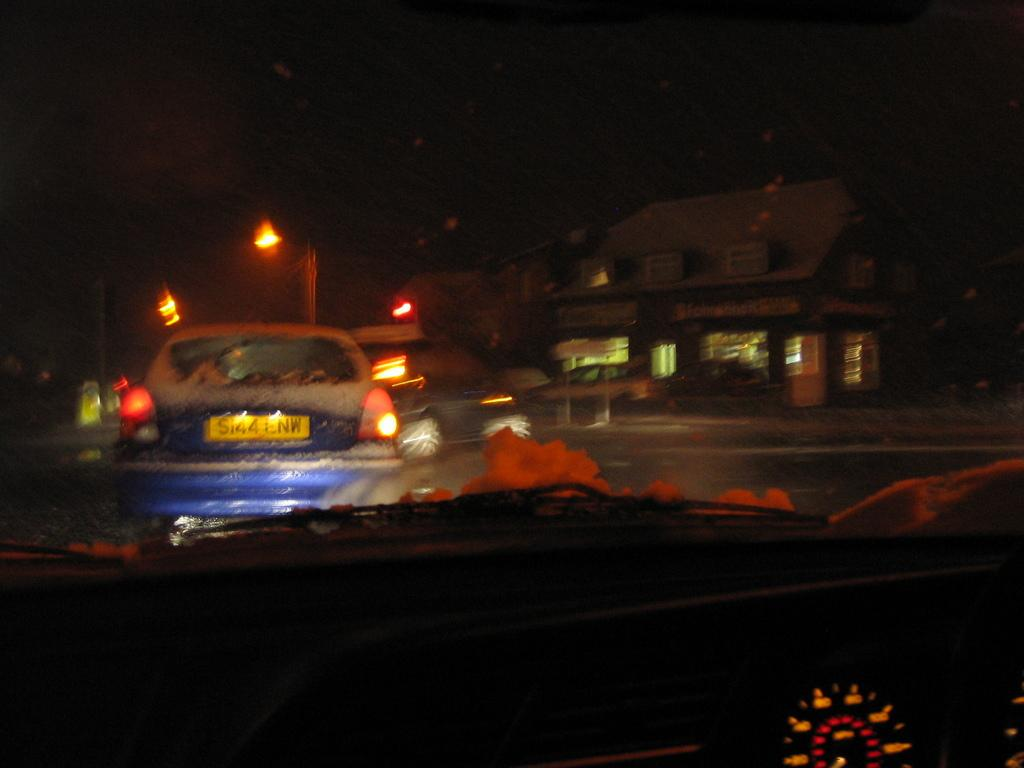What instrument is visible in the image for measuring speed? The speedometer is visible in the image. What is happening on the road in the image? Vehicles are passing on the road in the image. What can be seen in the image that provides illumination? There are lights in the image. What type of structure can be seen in the image? There is a building in the image. When was the image taken, based on the visibility of the surroundings? The image was taken during night time. What caption is written on the front of the building in the image? There is no caption visible on the front of the building in the image. What story is being told by the vehicles passing on the road in the image? The image does not tell a specific story; it simply shows vehicles passing on the road. 